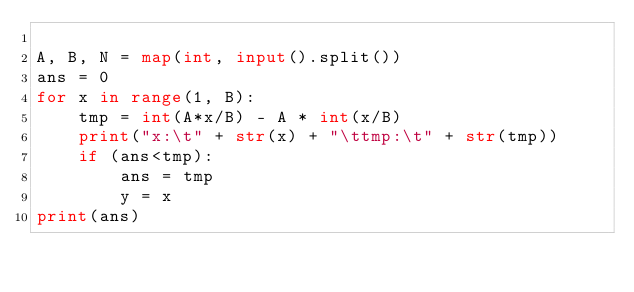<code> <loc_0><loc_0><loc_500><loc_500><_Python_> 
A, B, N = map(int, input().split())
ans = 0
for x in range(1, B):
    tmp = int(A*x/B) - A * int(x/B)
    print("x:\t" + str(x) + "\ttmp:\t" + str(tmp))
    if (ans<tmp):
        ans = tmp
        y = x
print(ans)</code> 